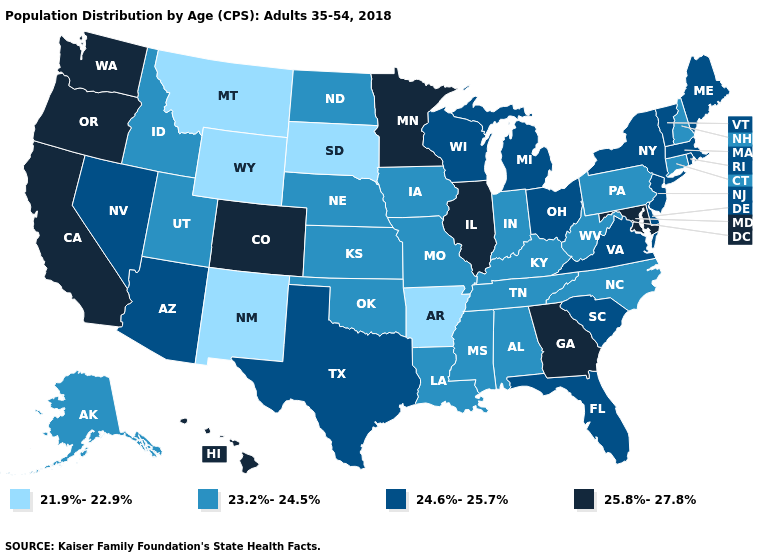What is the value of Alaska?
Keep it brief. 23.2%-24.5%. Does California have the same value as Georgia?
Write a very short answer. Yes. Name the states that have a value in the range 23.2%-24.5%?
Short answer required. Alabama, Alaska, Connecticut, Idaho, Indiana, Iowa, Kansas, Kentucky, Louisiana, Mississippi, Missouri, Nebraska, New Hampshire, North Carolina, North Dakota, Oklahoma, Pennsylvania, Tennessee, Utah, West Virginia. Among the states that border Oregon , does California have the highest value?
Give a very brief answer. Yes. Name the states that have a value in the range 25.8%-27.8%?
Concise answer only. California, Colorado, Georgia, Hawaii, Illinois, Maryland, Minnesota, Oregon, Washington. What is the value of Louisiana?
Answer briefly. 23.2%-24.5%. Name the states that have a value in the range 25.8%-27.8%?
Short answer required. California, Colorado, Georgia, Hawaii, Illinois, Maryland, Minnesota, Oregon, Washington. Which states have the lowest value in the West?
Be succinct. Montana, New Mexico, Wyoming. What is the highest value in the USA?
Quick response, please. 25.8%-27.8%. Among the states that border New Mexico , which have the highest value?
Quick response, please. Colorado. What is the value of Montana?
Keep it brief. 21.9%-22.9%. What is the highest value in the South ?
Quick response, please. 25.8%-27.8%. What is the value of West Virginia?
Be succinct. 23.2%-24.5%. Among the states that border Kentucky , does Illinois have the highest value?
Short answer required. Yes. Does North Dakota have the same value as Pennsylvania?
Short answer required. Yes. 